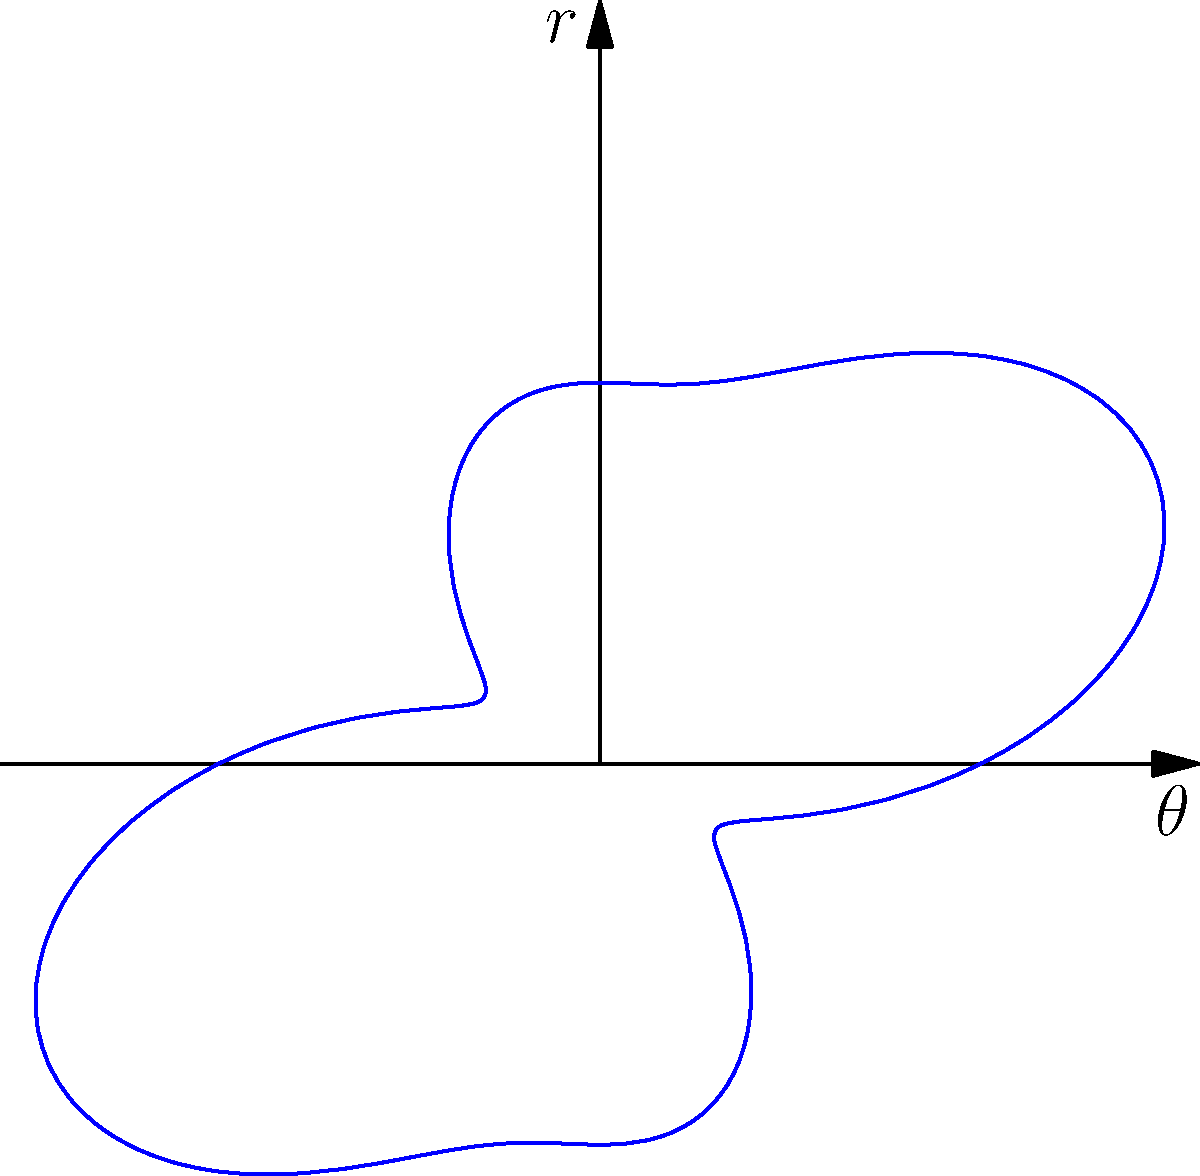In a surround sound setup for a cinematic experience, the intensity of sound waves is represented by the polar equation $r = 2 + \sin(2\theta) + 0.5\sin(4\theta)$. What is the maximum intensity of the sound waves, and at which angle(s) does it occur? To find the maximum intensity and its corresponding angle(s), we need to follow these steps:

1) The intensity is represented by the radius $r$ in the polar equation:
   $r = 2 + \sin(2\theta) + 0.5\sin(4\theta)$

2) To find the maximum value of $r$, we need to consider the maximum possible values of the sine functions:
   - $\sin(2\theta)$ has a maximum value of 1
   - $\sin(4\theta)$ has a maximum value of 1

3) The maximum value of $r$ occurs when both sine functions are at their maximum:
   $r_{max} = 2 + 1 + 0.5 = 3.5$

4) To find the angle(s) where this maximum occurs, we need to solve:
   $\sin(2\theta) = 1$ and $\sin(4\theta) = 1$ simultaneously

5) $\sin(2\theta) = 1$ occurs when $2\theta = \frac{\pi}{2} + 2\pi n$, where $n$ is an integer
   This means $\theta = \frac{\pi}{4} + \pi n$

6) $\sin(4\theta) = 1$ occurs when $4\theta = \frac{\pi}{2} + 2\pi m$, where $m$ is an integer
   This means $\theta = \frac{\pi}{8} + \frac{\pi}{2} m$

7) For these to be true simultaneously, we need:
   $\frac{\pi}{4} + \pi n = \frac{\pi}{8} + \frac{\pi}{2} m$

8) Solving this, we get $\theta = \frac{\pi}{8}$ (and its periodic repetitions)

Therefore, the maximum intensity is 3.5, occurring at angles $\theta = \frac{\pi}{8} + \frac{\pi}{4}k$, where $k$ is an integer.
Answer: Maximum intensity: 3.5; Angles: $\frac{\pi}{8} + \frac{\pi}{4}k$, $k \in \mathbb{Z}$ 